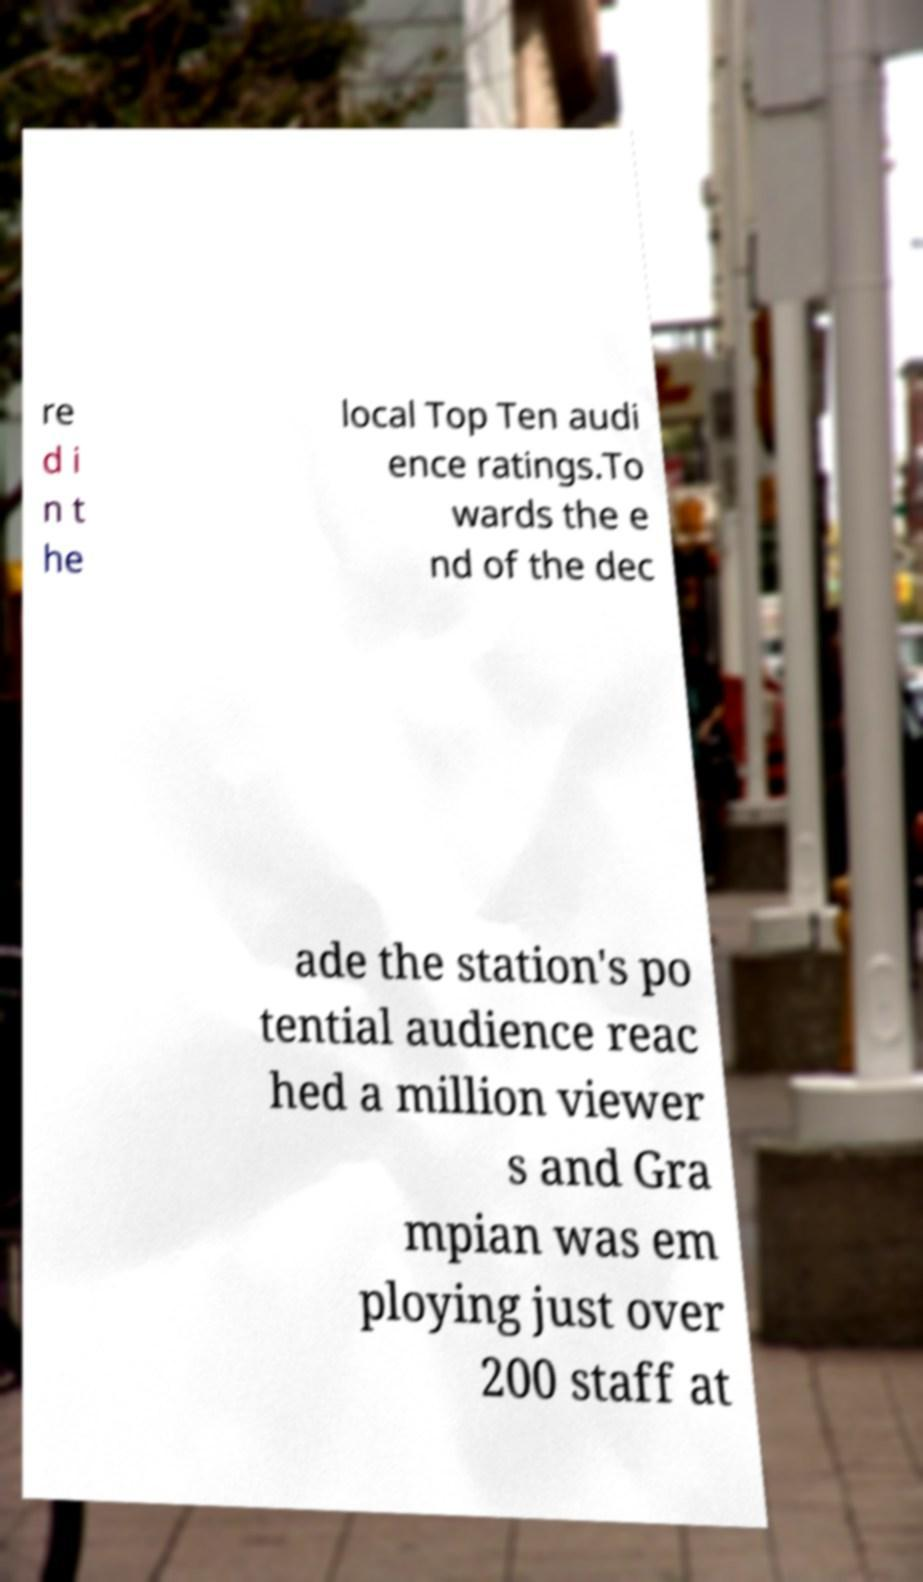Please read and relay the text visible in this image. What does it say? re d i n t he local Top Ten audi ence ratings.To wards the e nd of the dec ade the station's po tential audience reac hed a million viewer s and Gra mpian was em ploying just over 200 staff at 